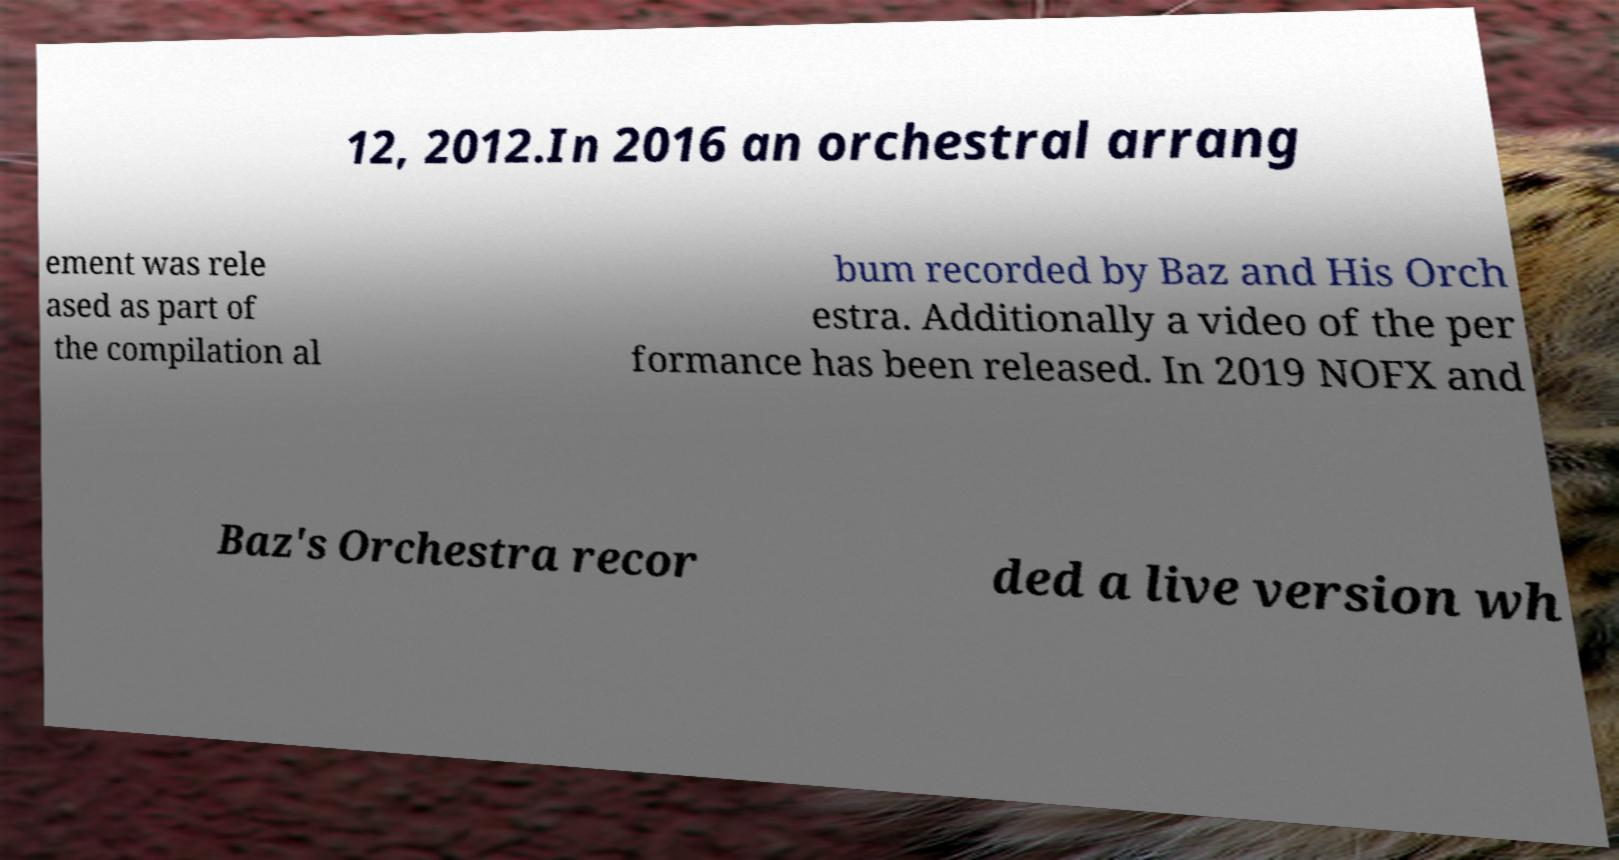I need the written content from this picture converted into text. Can you do that? 12, 2012.In 2016 an orchestral arrang ement was rele ased as part of the compilation al bum recorded by Baz and His Orch estra. Additionally a video of the per formance has been released. In 2019 NOFX and Baz's Orchestra recor ded a live version wh 